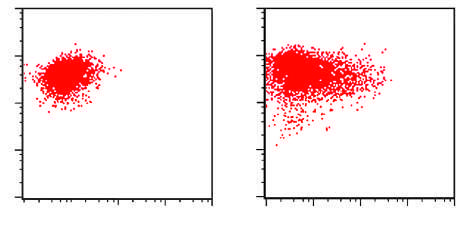re the normal areas dna content and the zygosity plot positive for the stem cell marker cd34 and the myeloid lineage specific markers cd33 and cd15 subset?
Answer the question using a single word or phrase. No 